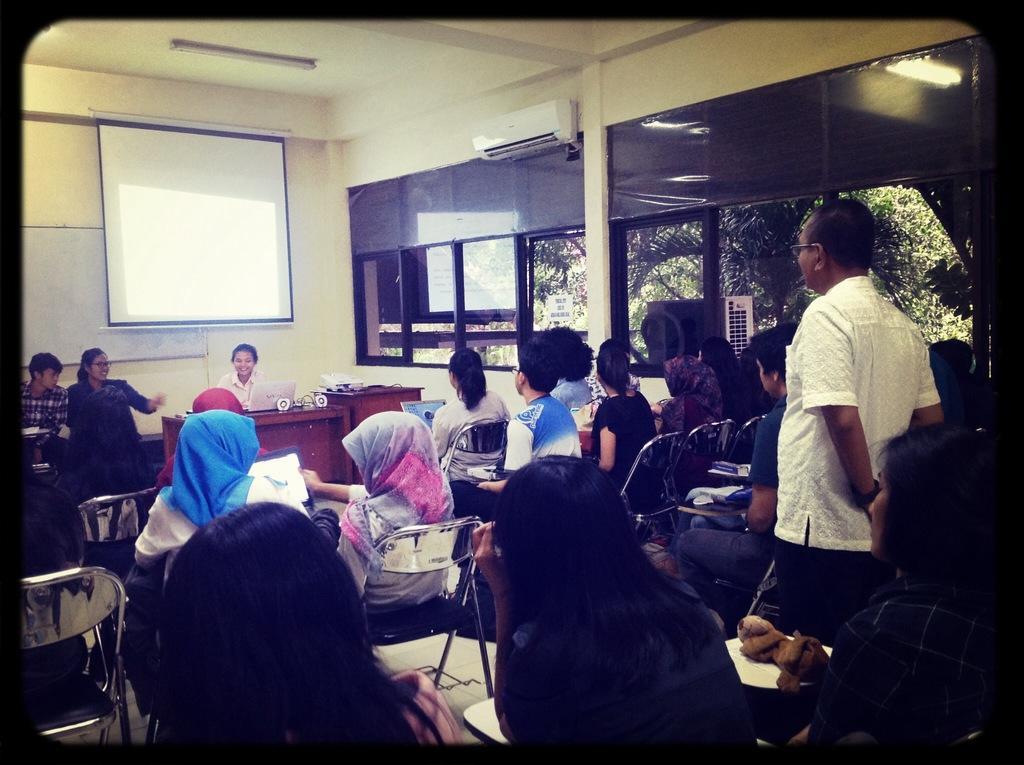Describe this image in one or two sentences. The picture is clicked inside a room where there are several people sitting on the chairs with notebooks in their hands. A guy who is wearing a white shirt stood up and talking with the person sitting on the table. There are two people sitting on the chair to the left side of the image and there is a white screen to the right side of the image. 